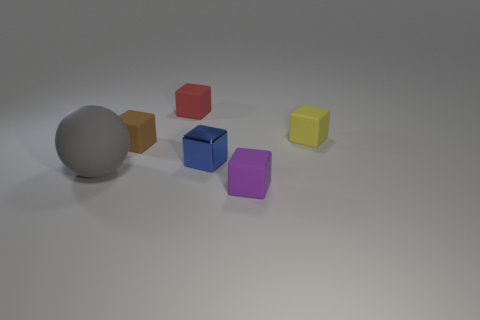There is a purple rubber thing that is the same size as the red object; what is its shape?
Ensure brevity in your answer.  Cube. Are the tiny thing that is in front of the tiny blue thing and the red object that is to the right of the matte ball made of the same material?
Your answer should be compact. Yes. There is a small thing in front of the matte ball that is left of the blue metallic block; what is its material?
Keep it short and to the point. Rubber. What is the size of the cube that is behind the thing that is to the right of the tiny matte object in front of the gray thing?
Your response must be concise. Small. Do the yellow thing and the red object have the same size?
Give a very brief answer. Yes. There is a small object that is behind the yellow thing; is it the same shape as the small object that is to the left of the small red block?
Your answer should be compact. Yes. There is a small rubber thing that is in front of the small brown matte cube; are there any purple rubber objects in front of it?
Offer a very short reply. No. Are there any tiny yellow objects?
Ensure brevity in your answer.  Yes. How many red rubber cubes are the same size as the matte sphere?
Keep it short and to the point. 0. How many objects are both in front of the brown thing and right of the big gray object?
Keep it short and to the point. 2. 